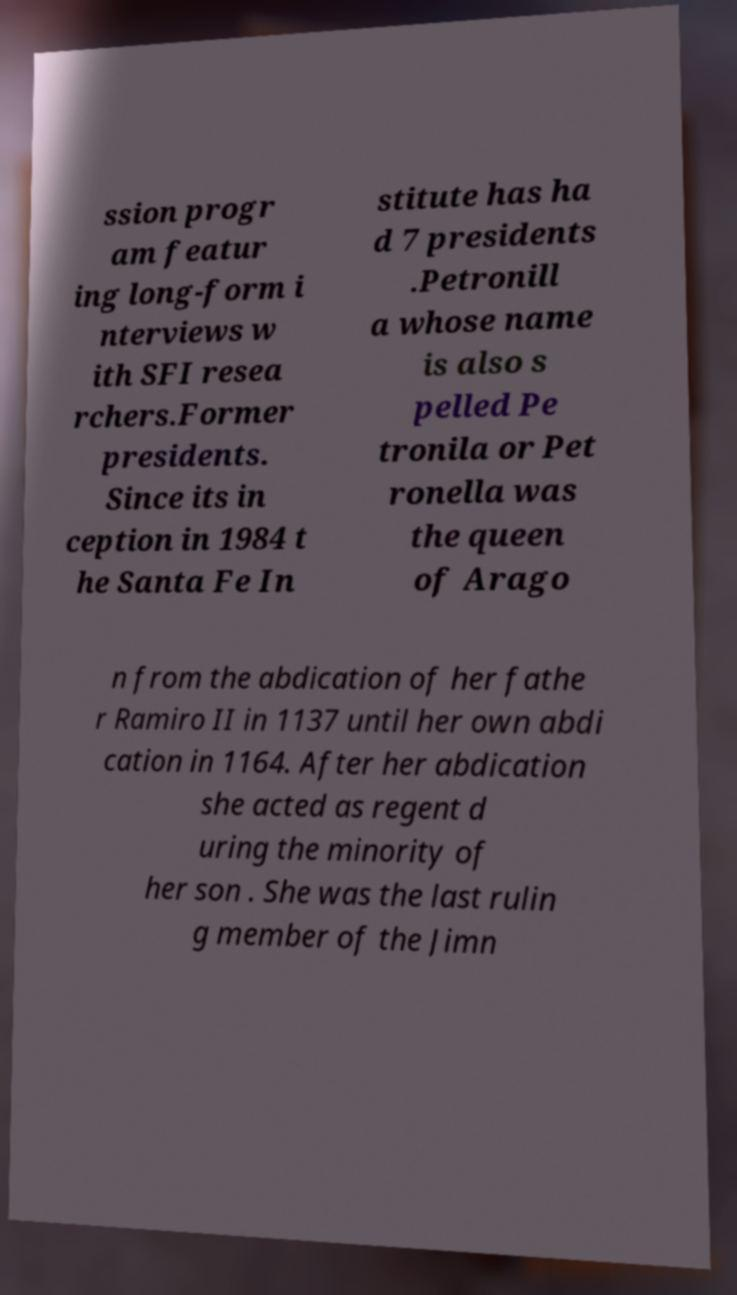Please identify and transcribe the text found in this image. ssion progr am featur ing long-form i nterviews w ith SFI resea rchers.Former presidents. Since its in ception in 1984 t he Santa Fe In stitute has ha d 7 presidents .Petronill a whose name is also s pelled Pe tronila or Pet ronella was the queen of Arago n from the abdication of her fathe r Ramiro II in 1137 until her own abdi cation in 1164. After her abdication she acted as regent d uring the minority of her son . She was the last rulin g member of the Jimn 